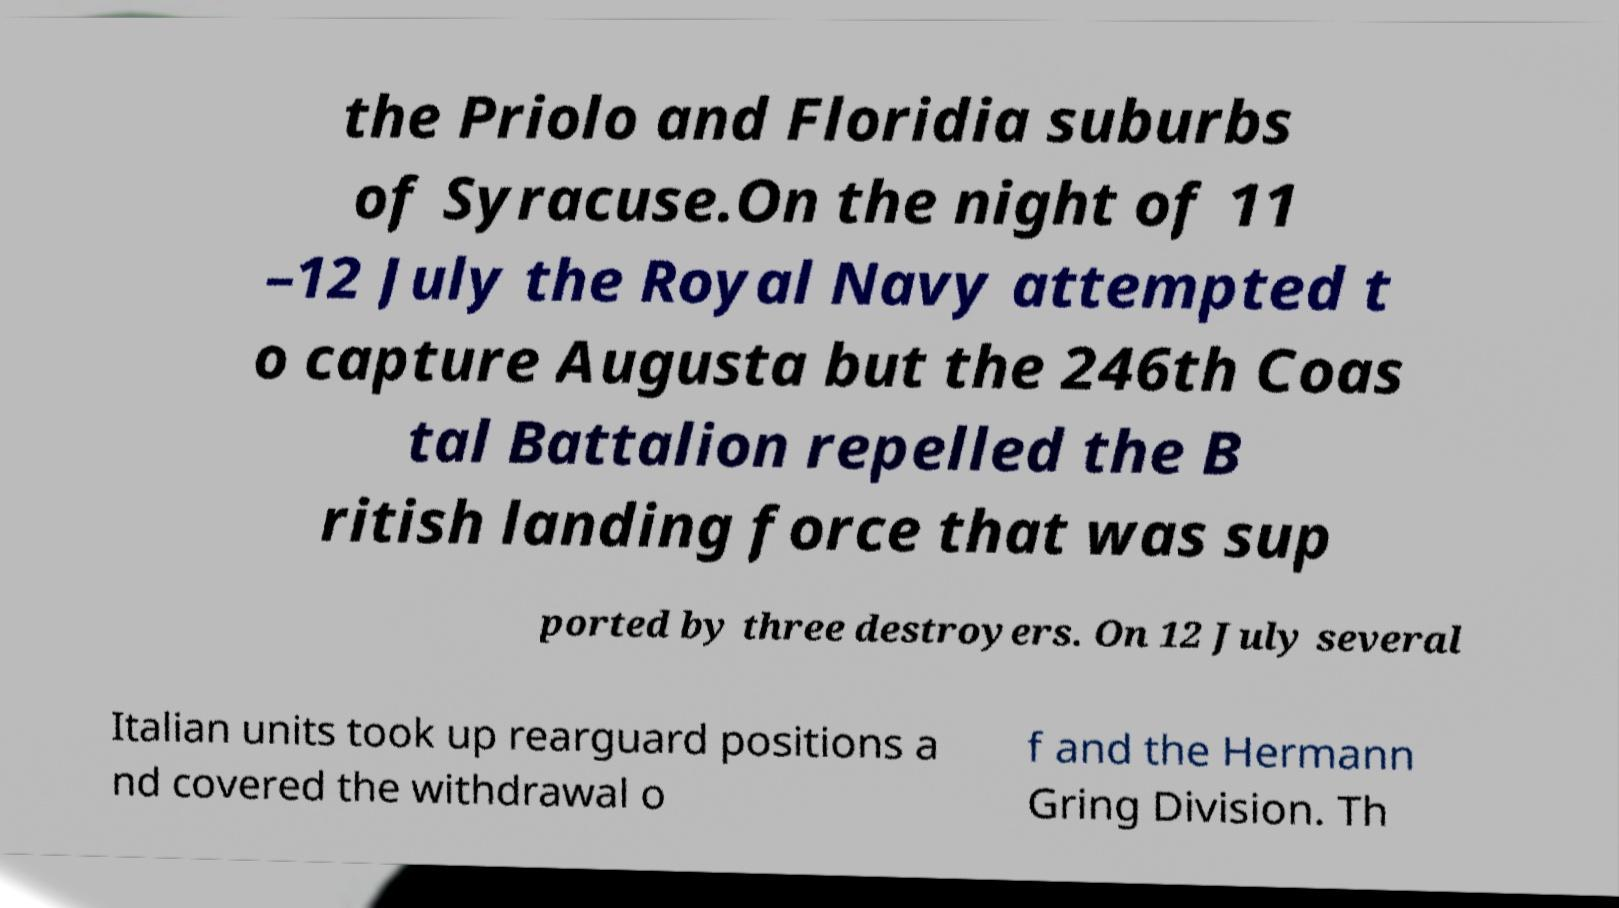What messages or text are displayed in this image? I need them in a readable, typed format. the Priolo and Floridia suburbs of Syracuse.On the night of 11 –12 July the Royal Navy attempted t o capture Augusta but the 246th Coas tal Battalion repelled the B ritish landing force that was sup ported by three destroyers. On 12 July several Italian units took up rearguard positions a nd covered the withdrawal o f and the Hermann Gring Division. Th 